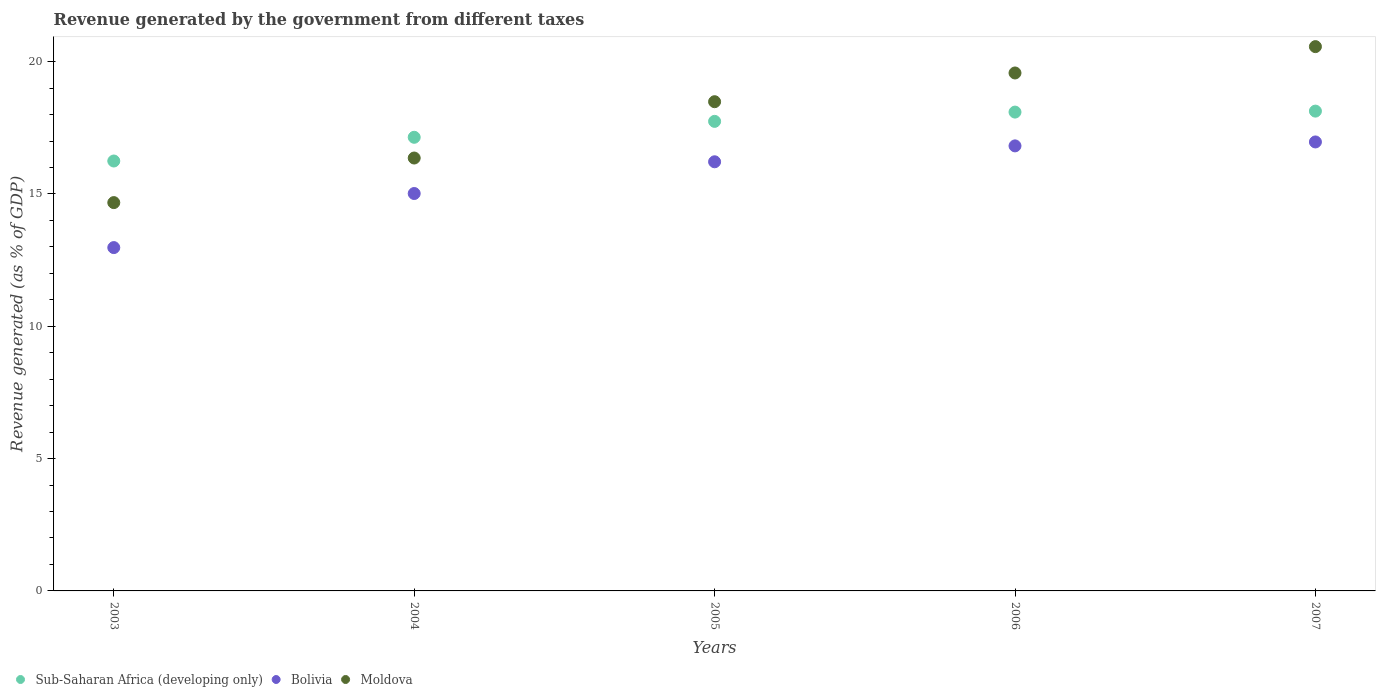How many different coloured dotlines are there?
Your answer should be compact. 3. Is the number of dotlines equal to the number of legend labels?
Provide a short and direct response. Yes. What is the revenue generated by the government in Sub-Saharan Africa (developing only) in 2007?
Offer a very short reply. 18.13. Across all years, what is the maximum revenue generated by the government in Bolivia?
Your response must be concise. 16.96. Across all years, what is the minimum revenue generated by the government in Moldova?
Your answer should be compact. 14.67. In which year was the revenue generated by the government in Bolivia maximum?
Give a very brief answer. 2007. What is the total revenue generated by the government in Moldova in the graph?
Provide a short and direct response. 89.65. What is the difference between the revenue generated by the government in Sub-Saharan Africa (developing only) in 2004 and that in 2006?
Offer a terse response. -0.95. What is the difference between the revenue generated by the government in Bolivia in 2006 and the revenue generated by the government in Moldova in 2004?
Your answer should be compact. 0.46. What is the average revenue generated by the government in Sub-Saharan Africa (developing only) per year?
Your answer should be compact. 17.47. In the year 2004, what is the difference between the revenue generated by the government in Bolivia and revenue generated by the government in Moldova?
Keep it short and to the point. -1.34. In how many years, is the revenue generated by the government in Bolivia greater than 7 %?
Your answer should be very brief. 5. What is the ratio of the revenue generated by the government in Bolivia in 2003 to that in 2006?
Your response must be concise. 0.77. What is the difference between the highest and the second highest revenue generated by the government in Moldova?
Make the answer very short. 1. What is the difference between the highest and the lowest revenue generated by the government in Sub-Saharan Africa (developing only)?
Your answer should be compact. 1.89. In how many years, is the revenue generated by the government in Bolivia greater than the average revenue generated by the government in Bolivia taken over all years?
Provide a succinct answer. 3. Is the revenue generated by the government in Bolivia strictly less than the revenue generated by the government in Sub-Saharan Africa (developing only) over the years?
Offer a very short reply. Yes. How many years are there in the graph?
Offer a very short reply. 5. What is the difference between two consecutive major ticks on the Y-axis?
Provide a short and direct response. 5. Are the values on the major ticks of Y-axis written in scientific E-notation?
Offer a very short reply. No. Does the graph contain any zero values?
Ensure brevity in your answer.  No. What is the title of the graph?
Provide a succinct answer. Revenue generated by the government from different taxes. What is the label or title of the X-axis?
Keep it short and to the point. Years. What is the label or title of the Y-axis?
Your response must be concise. Revenue generated (as % of GDP). What is the Revenue generated (as % of GDP) in Sub-Saharan Africa (developing only) in 2003?
Your answer should be compact. 16.24. What is the Revenue generated (as % of GDP) of Bolivia in 2003?
Provide a short and direct response. 12.97. What is the Revenue generated (as % of GDP) of Moldova in 2003?
Your answer should be compact. 14.67. What is the Revenue generated (as % of GDP) of Sub-Saharan Africa (developing only) in 2004?
Make the answer very short. 17.14. What is the Revenue generated (as % of GDP) of Bolivia in 2004?
Ensure brevity in your answer.  15.02. What is the Revenue generated (as % of GDP) of Moldova in 2004?
Provide a succinct answer. 16.36. What is the Revenue generated (as % of GDP) in Sub-Saharan Africa (developing only) in 2005?
Keep it short and to the point. 17.74. What is the Revenue generated (as % of GDP) in Bolivia in 2005?
Make the answer very short. 16.22. What is the Revenue generated (as % of GDP) in Moldova in 2005?
Ensure brevity in your answer.  18.49. What is the Revenue generated (as % of GDP) in Sub-Saharan Africa (developing only) in 2006?
Offer a terse response. 18.09. What is the Revenue generated (as % of GDP) in Bolivia in 2006?
Your answer should be compact. 16.82. What is the Revenue generated (as % of GDP) in Moldova in 2006?
Offer a very short reply. 19.57. What is the Revenue generated (as % of GDP) of Sub-Saharan Africa (developing only) in 2007?
Give a very brief answer. 18.13. What is the Revenue generated (as % of GDP) in Bolivia in 2007?
Your answer should be compact. 16.96. What is the Revenue generated (as % of GDP) in Moldova in 2007?
Your answer should be very brief. 20.57. Across all years, what is the maximum Revenue generated (as % of GDP) of Sub-Saharan Africa (developing only)?
Offer a terse response. 18.13. Across all years, what is the maximum Revenue generated (as % of GDP) of Bolivia?
Give a very brief answer. 16.96. Across all years, what is the maximum Revenue generated (as % of GDP) of Moldova?
Provide a succinct answer. 20.57. Across all years, what is the minimum Revenue generated (as % of GDP) of Sub-Saharan Africa (developing only)?
Your answer should be compact. 16.24. Across all years, what is the minimum Revenue generated (as % of GDP) of Bolivia?
Give a very brief answer. 12.97. Across all years, what is the minimum Revenue generated (as % of GDP) of Moldova?
Give a very brief answer. 14.67. What is the total Revenue generated (as % of GDP) of Sub-Saharan Africa (developing only) in the graph?
Make the answer very short. 87.35. What is the total Revenue generated (as % of GDP) of Bolivia in the graph?
Offer a terse response. 77.99. What is the total Revenue generated (as % of GDP) in Moldova in the graph?
Provide a short and direct response. 89.65. What is the difference between the Revenue generated (as % of GDP) in Sub-Saharan Africa (developing only) in 2003 and that in 2004?
Offer a very short reply. -0.9. What is the difference between the Revenue generated (as % of GDP) in Bolivia in 2003 and that in 2004?
Make the answer very short. -2.04. What is the difference between the Revenue generated (as % of GDP) in Moldova in 2003 and that in 2004?
Offer a very short reply. -1.68. What is the difference between the Revenue generated (as % of GDP) in Sub-Saharan Africa (developing only) in 2003 and that in 2005?
Provide a short and direct response. -1.5. What is the difference between the Revenue generated (as % of GDP) in Bolivia in 2003 and that in 2005?
Provide a short and direct response. -3.24. What is the difference between the Revenue generated (as % of GDP) in Moldova in 2003 and that in 2005?
Offer a terse response. -3.81. What is the difference between the Revenue generated (as % of GDP) of Sub-Saharan Africa (developing only) in 2003 and that in 2006?
Give a very brief answer. -1.85. What is the difference between the Revenue generated (as % of GDP) of Bolivia in 2003 and that in 2006?
Keep it short and to the point. -3.84. What is the difference between the Revenue generated (as % of GDP) in Moldova in 2003 and that in 2006?
Make the answer very short. -4.9. What is the difference between the Revenue generated (as % of GDP) of Sub-Saharan Africa (developing only) in 2003 and that in 2007?
Your answer should be very brief. -1.89. What is the difference between the Revenue generated (as % of GDP) of Bolivia in 2003 and that in 2007?
Keep it short and to the point. -3.99. What is the difference between the Revenue generated (as % of GDP) in Moldova in 2003 and that in 2007?
Ensure brevity in your answer.  -5.89. What is the difference between the Revenue generated (as % of GDP) of Sub-Saharan Africa (developing only) in 2004 and that in 2005?
Keep it short and to the point. -0.6. What is the difference between the Revenue generated (as % of GDP) in Bolivia in 2004 and that in 2005?
Ensure brevity in your answer.  -1.2. What is the difference between the Revenue generated (as % of GDP) of Moldova in 2004 and that in 2005?
Offer a terse response. -2.13. What is the difference between the Revenue generated (as % of GDP) in Sub-Saharan Africa (developing only) in 2004 and that in 2006?
Provide a succinct answer. -0.95. What is the difference between the Revenue generated (as % of GDP) of Bolivia in 2004 and that in 2006?
Provide a succinct answer. -1.8. What is the difference between the Revenue generated (as % of GDP) in Moldova in 2004 and that in 2006?
Your answer should be very brief. -3.21. What is the difference between the Revenue generated (as % of GDP) of Sub-Saharan Africa (developing only) in 2004 and that in 2007?
Keep it short and to the point. -0.99. What is the difference between the Revenue generated (as % of GDP) in Bolivia in 2004 and that in 2007?
Provide a succinct answer. -1.95. What is the difference between the Revenue generated (as % of GDP) of Moldova in 2004 and that in 2007?
Offer a very short reply. -4.21. What is the difference between the Revenue generated (as % of GDP) in Sub-Saharan Africa (developing only) in 2005 and that in 2006?
Provide a succinct answer. -0.35. What is the difference between the Revenue generated (as % of GDP) of Bolivia in 2005 and that in 2006?
Offer a terse response. -0.6. What is the difference between the Revenue generated (as % of GDP) in Moldova in 2005 and that in 2006?
Give a very brief answer. -1.09. What is the difference between the Revenue generated (as % of GDP) in Sub-Saharan Africa (developing only) in 2005 and that in 2007?
Give a very brief answer. -0.39. What is the difference between the Revenue generated (as % of GDP) in Bolivia in 2005 and that in 2007?
Ensure brevity in your answer.  -0.75. What is the difference between the Revenue generated (as % of GDP) of Moldova in 2005 and that in 2007?
Provide a succinct answer. -2.08. What is the difference between the Revenue generated (as % of GDP) in Sub-Saharan Africa (developing only) in 2006 and that in 2007?
Ensure brevity in your answer.  -0.04. What is the difference between the Revenue generated (as % of GDP) in Bolivia in 2006 and that in 2007?
Your response must be concise. -0.15. What is the difference between the Revenue generated (as % of GDP) in Moldova in 2006 and that in 2007?
Provide a succinct answer. -1. What is the difference between the Revenue generated (as % of GDP) in Sub-Saharan Africa (developing only) in 2003 and the Revenue generated (as % of GDP) in Bolivia in 2004?
Give a very brief answer. 1.23. What is the difference between the Revenue generated (as % of GDP) in Sub-Saharan Africa (developing only) in 2003 and the Revenue generated (as % of GDP) in Moldova in 2004?
Give a very brief answer. -0.11. What is the difference between the Revenue generated (as % of GDP) of Bolivia in 2003 and the Revenue generated (as % of GDP) of Moldova in 2004?
Ensure brevity in your answer.  -3.38. What is the difference between the Revenue generated (as % of GDP) in Sub-Saharan Africa (developing only) in 2003 and the Revenue generated (as % of GDP) in Bolivia in 2005?
Provide a succinct answer. 0.03. What is the difference between the Revenue generated (as % of GDP) of Sub-Saharan Africa (developing only) in 2003 and the Revenue generated (as % of GDP) of Moldova in 2005?
Ensure brevity in your answer.  -2.24. What is the difference between the Revenue generated (as % of GDP) of Bolivia in 2003 and the Revenue generated (as % of GDP) of Moldova in 2005?
Provide a short and direct response. -5.51. What is the difference between the Revenue generated (as % of GDP) in Sub-Saharan Africa (developing only) in 2003 and the Revenue generated (as % of GDP) in Bolivia in 2006?
Your answer should be compact. -0.57. What is the difference between the Revenue generated (as % of GDP) of Sub-Saharan Africa (developing only) in 2003 and the Revenue generated (as % of GDP) of Moldova in 2006?
Offer a terse response. -3.33. What is the difference between the Revenue generated (as % of GDP) in Bolivia in 2003 and the Revenue generated (as % of GDP) in Moldova in 2006?
Ensure brevity in your answer.  -6.6. What is the difference between the Revenue generated (as % of GDP) in Sub-Saharan Africa (developing only) in 2003 and the Revenue generated (as % of GDP) in Bolivia in 2007?
Offer a very short reply. -0.72. What is the difference between the Revenue generated (as % of GDP) in Sub-Saharan Africa (developing only) in 2003 and the Revenue generated (as % of GDP) in Moldova in 2007?
Provide a succinct answer. -4.32. What is the difference between the Revenue generated (as % of GDP) of Bolivia in 2003 and the Revenue generated (as % of GDP) of Moldova in 2007?
Offer a terse response. -7.59. What is the difference between the Revenue generated (as % of GDP) in Sub-Saharan Africa (developing only) in 2004 and the Revenue generated (as % of GDP) in Bolivia in 2005?
Provide a short and direct response. 0.93. What is the difference between the Revenue generated (as % of GDP) of Sub-Saharan Africa (developing only) in 2004 and the Revenue generated (as % of GDP) of Moldova in 2005?
Offer a very short reply. -1.34. What is the difference between the Revenue generated (as % of GDP) of Bolivia in 2004 and the Revenue generated (as % of GDP) of Moldova in 2005?
Ensure brevity in your answer.  -3.47. What is the difference between the Revenue generated (as % of GDP) of Sub-Saharan Africa (developing only) in 2004 and the Revenue generated (as % of GDP) of Bolivia in 2006?
Keep it short and to the point. 0.32. What is the difference between the Revenue generated (as % of GDP) in Sub-Saharan Africa (developing only) in 2004 and the Revenue generated (as % of GDP) in Moldova in 2006?
Offer a terse response. -2.43. What is the difference between the Revenue generated (as % of GDP) of Bolivia in 2004 and the Revenue generated (as % of GDP) of Moldova in 2006?
Provide a succinct answer. -4.55. What is the difference between the Revenue generated (as % of GDP) of Sub-Saharan Africa (developing only) in 2004 and the Revenue generated (as % of GDP) of Bolivia in 2007?
Make the answer very short. 0.18. What is the difference between the Revenue generated (as % of GDP) in Sub-Saharan Africa (developing only) in 2004 and the Revenue generated (as % of GDP) in Moldova in 2007?
Make the answer very short. -3.43. What is the difference between the Revenue generated (as % of GDP) of Bolivia in 2004 and the Revenue generated (as % of GDP) of Moldova in 2007?
Your answer should be compact. -5.55. What is the difference between the Revenue generated (as % of GDP) in Sub-Saharan Africa (developing only) in 2005 and the Revenue generated (as % of GDP) in Bolivia in 2006?
Your answer should be very brief. 0.93. What is the difference between the Revenue generated (as % of GDP) of Sub-Saharan Africa (developing only) in 2005 and the Revenue generated (as % of GDP) of Moldova in 2006?
Offer a very short reply. -1.83. What is the difference between the Revenue generated (as % of GDP) of Bolivia in 2005 and the Revenue generated (as % of GDP) of Moldova in 2006?
Provide a short and direct response. -3.36. What is the difference between the Revenue generated (as % of GDP) in Sub-Saharan Africa (developing only) in 2005 and the Revenue generated (as % of GDP) in Bolivia in 2007?
Keep it short and to the point. 0.78. What is the difference between the Revenue generated (as % of GDP) of Sub-Saharan Africa (developing only) in 2005 and the Revenue generated (as % of GDP) of Moldova in 2007?
Make the answer very short. -2.82. What is the difference between the Revenue generated (as % of GDP) of Bolivia in 2005 and the Revenue generated (as % of GDP) of Moldova in 2007?
Your response must be concise. -4.35. What is the difference between the Revenue generated (as % of GDP) in Sub-Saharan Africa (developing only) in 2006 and the Revenue generated (as % of GDP) in Bolivia in 2007?
Your answer should be compact. 1.13. What is the difference between the Revenue generated (as % of GDP) in Sub-Saharan Africa (developing only) in 2006 and the Revenue generated (as % of GDP) in Moldova in 2007?
Provide a succinct answer. -2.47. What is the difference between the Revenue generated (as % of GDP) of Bolivia in 2006 and the Revenue generated (as % of GDP) of Moldova in 2007?
Offer a terse response. -3.75. What is the average Revenue generated (as % of GDP) in Sub-Saharan Africa (developing only) per year?
Your answer should be compact. 17.47. What is the average Revenue generated (as % of GDP) of Bolivia per year?
Make the answer very short. 15.6. What is the average Revenue generated (as % of GDP) in Moldova per year?
Keep it short and to the point. 17.93. In the year 2003, what is the difference between the Revenue generated (as % of GDP) in Sub-Saharan Africa (developing only) and Revenue generated (as % of GDP) in Bolivia?
Keep it short and to the point. 3.27. In the year 2003, what is the difference between the Revenue generated (as % of GDP) of Sub-Saharan Africa (developing only) and Revenue generated (as % of GDP) of Moldova?
Provide a short and direct response. 1.57. In the year 2003, what is the difference between the Revenue generated (as % of GDP) in Bolivia and Revenue generated (as % of GDP) in Moldova?
Offer a terse response. -1.7. In the year 2004, what is the difference between the Revenue generated (as % of GDP) in Sub-Saharan Africa (developing only) and Revenue generated (as % of GDP) in Bolivia?
Keep it short and to the point. 2.12. In the year 2004, what is the difference between the Revenue generated (as % of GDP) in Sub-Saharan Africa (developing only) and Revenue generated (as % of GDP) in Moldova?
Your answer should be compact. 0.78. In the year 2004, what is the difference between the Revenue generated (as % of GDP) of Bolivia and Revenue generated (as % of GDP) of Moldova?
Your answer should be very brief. -1.34. In the year 2005, what is the difference between the Revenue generated (as % of GDP) of Sub-Saharan Africa (developing only) and Revenue generated (as % of GDP) of Bolivia?
Keep it short and to the point. 1.53. In the year 2005, what is the difference between the Revenue generated (as % of GDP) of Sub-Saharan Africa (developing only) and Revenue generated (as % of GDP) of Moldova?
Your response must be concise. -0.74. In the year 2005, what is the difference between the Revenue generated (as % of GDP) in Bolivia and Revenue generated (as % of GDP) in Moldova?
Offer a very short reply. -2.27. In the year 2006, what is the difference between the Revenue generated (as % of GDP) in Sub-Saharan Africa (developing only) and Revenue generated (as % of GDP) in Bolivia?
Give a very brief answer. 1.28. In the year 2006, what is the difference between the Revenue generated (as % of GDP) in Sub-Saharan Africa (developing only) and Revenue generated (as % of GDP) in Moldova?
Provide a succinct answer. -1.48. In the year 2006, what is the difference between the Revenue generated (as % of GDP) of Bolivia and Revenue generated (as % of GDP) of Moldova?
Provide a succinct answer. -2.75. In the year 2007, what is the difference between the Revenue generated (as % of GDP) of Sub-Saharan Africa (developing only) and Revenue generated (as % of GDP) of Bolivia?
Provide a succinct answer. 1.16. In the year 2007, what is the difference between the Revenue generated (as % of GDP) of Sub-Saharan Africa (developing only) and Revenue generated (as % of GDP) of Moldova?
Offer a very short reply. -2.44. In the year 2007, what is the difference between the Revenue generated (as % of GDP) of Bolivia and Revenue generated (as % of GDP) of Moldova?
Your answer should be compact. -3.6. What is the ratio of the Revenue generated (as % of GDP) of Sub-Saharan Africa (developing only) in 2003 to that in 2004?
Provide a succinct answer. 0.95. What is the ratio of the Revenue generated (as % of GDP) of Bolivia in 2003 to that in 2004?
Ensure brevity in your answer.  0.86. What is the ratio of the Revenue generated (as % of GDP) of Moldova in 2003 to that in 2004?
Provide a succinct answer. 0.9. What is the ratio of the Revenue generated (as % of GDP) of Sub-Saharan Africa (developing only) in 2003 to that in 2005?
Your response must be concise. 0.92. What is the ratio of the Revenue generated (as % of GDP) of Bolivia in 2003 to that in 2005?
Give a very brief answer. 0.8. What is the ratio of the Revenue generated (as % of GDP) of Moldova in 2003 to that in 2005?
Provide a short and direct response. 0.79. What is the ratio of the Revenue generated (as % of GDP) of Sub-Saharan Africa (developing only) in 2003 to that in 2006?
Provide a succinct answer. 0.9. What is the ratio of the Revenue generated (as % of GDP) of Bolivia in 2003 to that in 2006?
Make the answer very short. 0.77. What is the ratio of the Revenue generated (as % of GDP) in Moldova in 2003 to that in 2006?
Offer a very short reply. 0.75. What is the ratio of the Revenue generated (as % of GDP) of Sub-Saharan Africa (developing only) in 2003 to that in 2007?
Ensure brevity in your answer.  0.9. What is the ratio of the Revenue generated (as % of GDP) of Bolivia in 2003 to that in 2007?
Provide a short and direct response. 0.76. What is the ratio of the Revenue generated (as % of GDP) in Moldova in 2003 to that in 2007?
Offer a very short reply. 0.71. What is the ratio of the Revenue generated (as % of GDP) of Sub-Saharan Africa (developing only) in 2004 to that in 2005?
Your answer should be compact. 0.97. What is the ratio of the Revenue generated (as % of GDP) of Bolivia in 2004 to that in 2005?
Provide a succinct answer. 0.93. What is the ratio of the Revenue generated (as % of GDP) in Moldova in 2004 to that in 2005?
Give a very brief answer. 0.88. What is the ratio of the Revenue generated (as % of GDP) in Sub-Saharan Africa (developing only) in 2004 to that in 2006?
Provide a succinct answer. 0.95. What is the ratio of the Revenue generated (as % of GDP) of Bolivia in 2004 to that in 2006?
Offer a terse response. 0.89. What is the ratio of the Revenue generated (as % of GDP) in Moldova in 2004 to that in 2006?
Offer a very short reply. 0.84. What is the ratio of the Revenue generated (as % of GDP) of Sub-Saharan Africa (developing only) in 2004 to that in 2007?
Provide a short and direct response. 0.95. What is the ratio of the Revenue generated (as % of GDP) in Bolivia in 2004 to that in 2007?
Your answer should be compact. 0.89. What is the ratio of the Revenue generated (as % of GDP) in Moldova in 2004 to that in 2007?
Your answer should be compact. 0.8. What is the ratio of the Revenue generated (as % of GDP) in Sub-Saharan Africa (developing only) in 2005 to that in 2006?
Give a very brief answer. 0.98. What is the ratio of the Revenue generated (as % of GDP) of Bolivia in 2005 to that in 2006?
Your answer should be very brief. 0.96. What is the ratio of the Revenue generated (as % of GDP) in Moldova in 2005 to that in 2006?
Your response must be concise. 0.94. What is the ratio of the Revenue generated (as % of GDP) of Sub-Saharan Africa (developing only) in 2005 to that in 2007?
Your answer should be compact. 0.98. What is the ratio of the Revenue generated (as % of GDP) in Bolivia in 2005 to that in 2007?
Provide a short and direct response. 0.96. What is the ratio of the Revenue generated (as % of GDP) in Moldova in 2005 to that in 2007?
Provide a short and direct response. 0.9. What is the ratio of the Revenue generated (as % of GDP) of Bolivia in 2006 to that in 2007?
Ensure brevity in your answer.  0.99. What is the ratio of the Revenue generated (as % of GDP) of Moldova in 2006 to that in 2007?
Give a very brief answer. 0.95. What is the difference between the highest and the second highest Revenue generated (as % of GDP) in Sub-Saharan Africa (developing only)?
Your response must be concise. 0.04. What is the difference between the highest and the second highest Revenue generated (as % of GDP) of Bolivia?
Ensure brevity in your answer.  0.15. What is the difference between the highest and the lowest Revenue generated (as % of GDP) of Sub-Saharan Africa (developing only)?
Provide a short and direct response. 1.89. What is the difference between the highest and the lowest Revenue generated (as % of GDP) of Bolivia?
Offer a terse response. 3.99. What is the difference between the highest and the lowest Revenue generated (as % of GDP) in Moldova?
Provide a succinct answer. 5.89. 